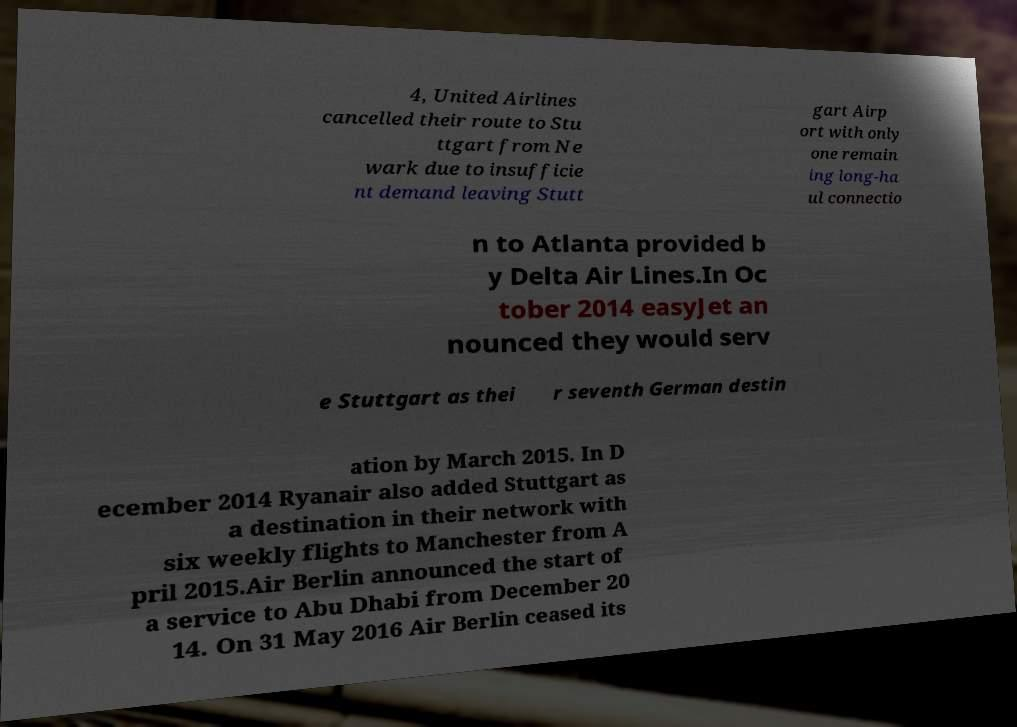Could you assist in decoding the text presented in this image and type it out clearly? 4, United Airlines cancelled their route to Stu ttgart from Ne wark due to insufficie nt demand leaving Stutt gart Airp ort with only one remain ing long-ha ul connectio n to Atlanta provided b y Delta Air Lines.In Oc tober 2014 easyJet an nounced they would serv e Stuttgart as thei r seventh German destin ation by March 2015. In D ecember 2014 Ryanair also added Stuttgart as a destination in their network with six weekly flights to Manchester from A pril 2015.Air Berlin announced the start of a service to Abu Dhabi from December 20 14. On 31 May 2016 Air Berlin ceased its 